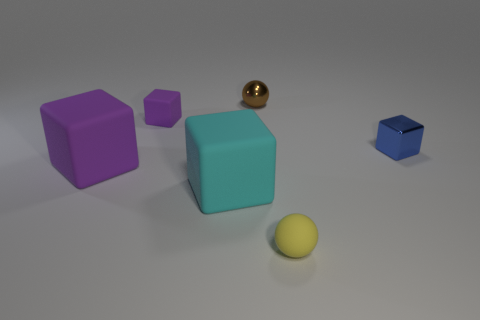If we were to put all these objects into a container, which one would most likely go in last due to its size? Considering the relative sizes of the objects in the image, the large purple cube would likely be the last to fit into a container because of its larger dimensions. 